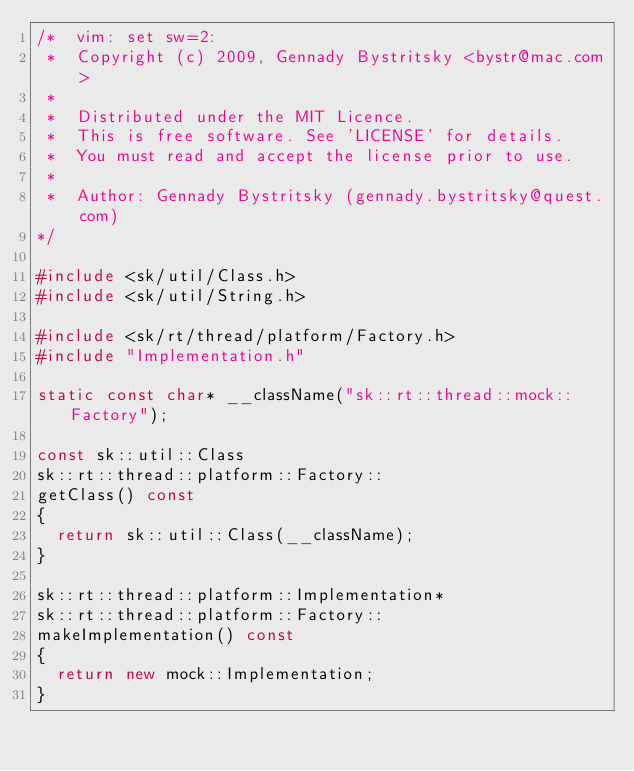Convert code to text. <code><loc_0><loc_0><loc_500><loc_500><_C++_>/*  vim: set sw=2:
 *  Copyright (c) 2009, Gennady Bystritsky <bystr@mac.com>
 *
 *  Distributed under the MIT Licence.
 *  This is free software. See 'LICENSE' for details.
 *  You must read and accept the license prior to use.
 *
 *  Author: Gennady Bystritsky (gennady.bystritsky@quest.com)
*/

#include <sk/util/Class.h>
#include <sk/util/String.h>

#include <sk/rt/thread/platform/Factory.h>
#include "Implementation.h"

static const char* __className("sk::rt::thread::mock::Factory");

const sk::util::Class
sk::rt::thread::platform::Factory::
getClass() const
{
  return sk::util::Class(__className);
}

sk::rt::thread::platform::Implementation*
sk::rt::thread::platform::Factory::
makeImplementation() const
{
  return new mock::Implementation;
}
</code> 